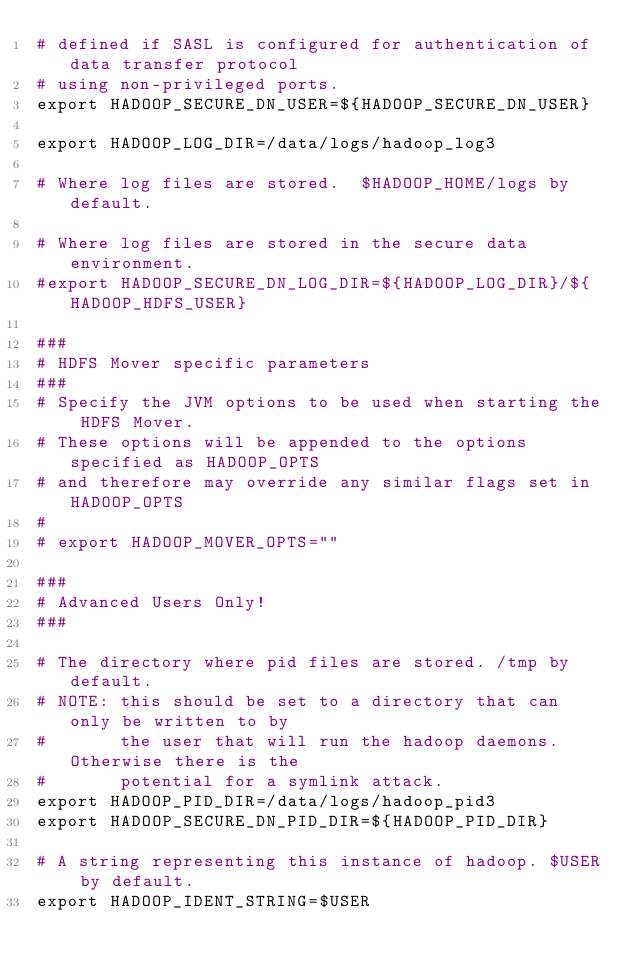<code> <loc_0><loc_0><loc_500><loc_500><_Bash_># defined if SASL is configured for authentication of data transfer protocol
# using non-privileged ports.
export HADOOP_SECURE_DN_USER=${HADOOP_SECURE_DN_USER}

export HADOOP_LOG_DIR=/data/logs/hadoop_log3

# Where log files are stored.  $HADOOP_HOME/logs by default.

# Where log files are stored in the secure data environment.
#export HADOOP_SECURE_DN_LOG_DIR=${HADOOP_LOG_DIR}/${HADOOP_HDFS_USER}

###
# HDFS Mover specific parameters
###
# Specify the JVM options to be used when starting the HDFS Mover.
# These options will be appended to the options specified as HADOOP_OPTS
# and therefore may override any similar flags set in HADOOP_OPTS
#
# export HADOOP_MOVER_OPTS=""

###
# Advanced Users Only!
###

# The directory where pid files are stored. /tmp by default.
# NOTE: this should be set to a directory that can only be written to by 
#       the user that will run the hadoop daemons.  Otherwise there is the
#       potential for a symlink attack.
export HADOOP_PID_DIR=/data/logs/hadoop_pid3
export HADOOP_SECURE_DN_PID_DIR=${HADOOP_PID_DIR}

# A string representing this instance of hadoop. $USER by default.
export HADOOP_IDENT_STRING=$USER
</code> 